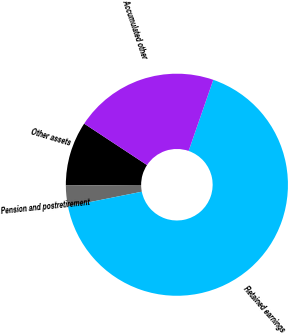<chart> <loc_0><loc_0><loc_500><loc_500><pie_chart><fcel>Other assets<fcel>Pension and postretirement<fcel>Retained earnings<fcel>Accumulated other<nl><fcel>9.38%<fcel>3.02%<fcel>66.55%<fcel>21.04%<nl></chart> 